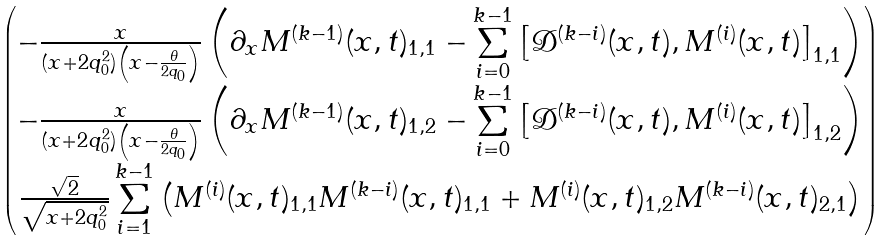<formula> <loc_0><loc_0><loc_500><loc_500>\begin{pmatrix} - \frac { x } { ( x + 2 q _ { 0 } ^ { 2 } ) \left ( x - \frac { \theta } { 2 q _ { 0 } } \right ) } \left ( \partial _ { x } M ^ { ( k - 1 ) } ( x , t ) _ { 1 , 1 } - \underset { i = 0 } { \overset { k - 1 } { \sum } } \left [ \mathcal { D } ^ { ( k - i ) } ( x , t ) , M ^ { ( i ) } ( x , t ) \right ] _ { 1 , 1 } \right ) \\ - \frac { x } { ( x + 2 q _ { 0 } ^ { 2 } ) \left ( x - \frac { \theta } { 2 q _ { 0 } } \right ) } \left ( \partial _ { x } M ^ { ( k - 1 ) } ( x , t ) _ { 1 , 2 } - \underset { i = 0 } { \overset { k - 1 } { \sum } } \left [ \mathcal { D } ^ { ( k - i ) } ( x , t ) , M ^ { ( i ) } ( x , t ) \right ] _ { 1 , 2 } \right ) \\ \frac { \sqrt { 2 } } { \sqrt { x + 2 q _ { 0 } ^ { 2 } } } \, \underset { i = 1 } { \overset { k - 1 } { \sum } } \left ( M ^ { ( i ) } ( x , t ) _ { 1 , 1 } M ^ { ( k - i ) } ( x , t ) _ { 1 , 1 } + M ^ { ( i ) } ( x , t ) _ { 1 , 2 } M ^ { ( k - i ) } ( x , t ) _ { 2 , 1 } \right ) \end{pmatrix}</formula> 